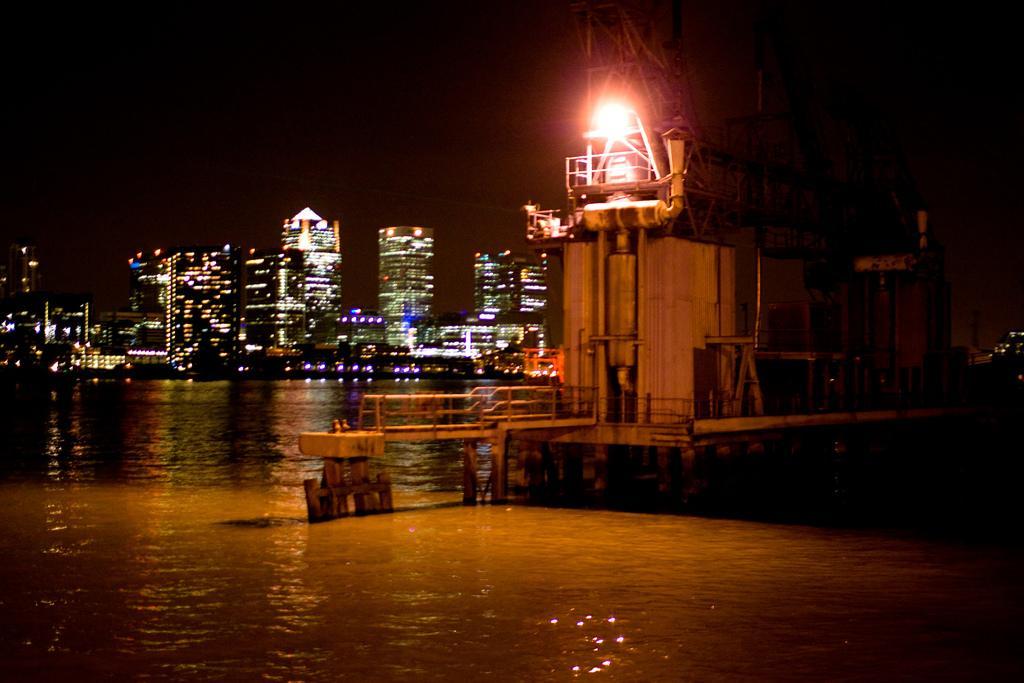Describe this image in one or two sentences. In this picture we can see water, an object and behind the water, there are buildings with lights. 